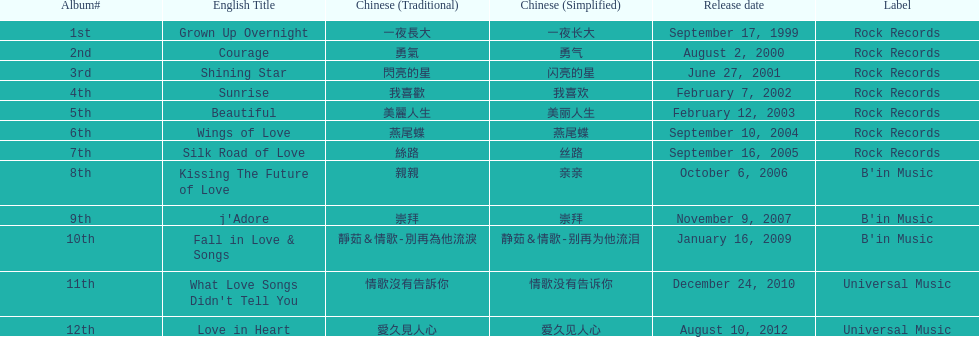What was the exclusive album released by b'in music during an even-numbered year? Kissing The Future of Love. 